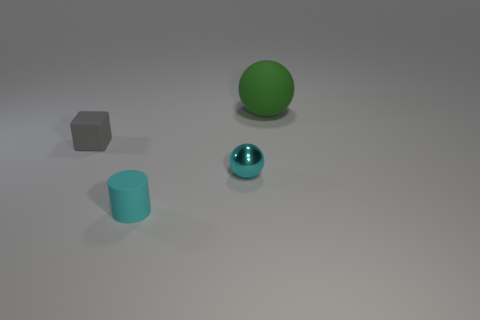Add 2 big things. How many objects exist? 6 Subtract 0 gray balls. How many objects are left? 4 Subtract all cylinders. How many objects are left? 3 Subtract all big brown objects. Subtract all cylinders. How many objects are left? 3 Add 4 large green spheres. How many large green spheres are left? 5 Add 4 big spheres. How many big spheres exist? 5 